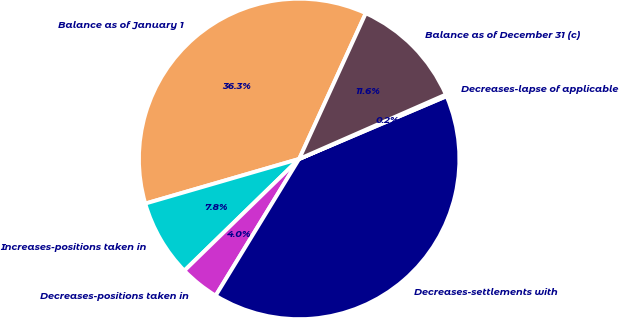<chart> <loc_0><loc_0><loc_500><loc_500><pie_chart><fcel>Balance as of January 1<fcel>Increases-positions taken in<fcel>Decreases-positions taken in<fcel>Decreases-settlements with<fcel>Decreases-lapse of applicable<fcel>Balance as of December 31 (c)<nl><fcel>36.32%<fcel>7.79%<fcel>3.99%<fcel>40.13%<fcel>0.18%<fcel>11.59%<nl></chart> 